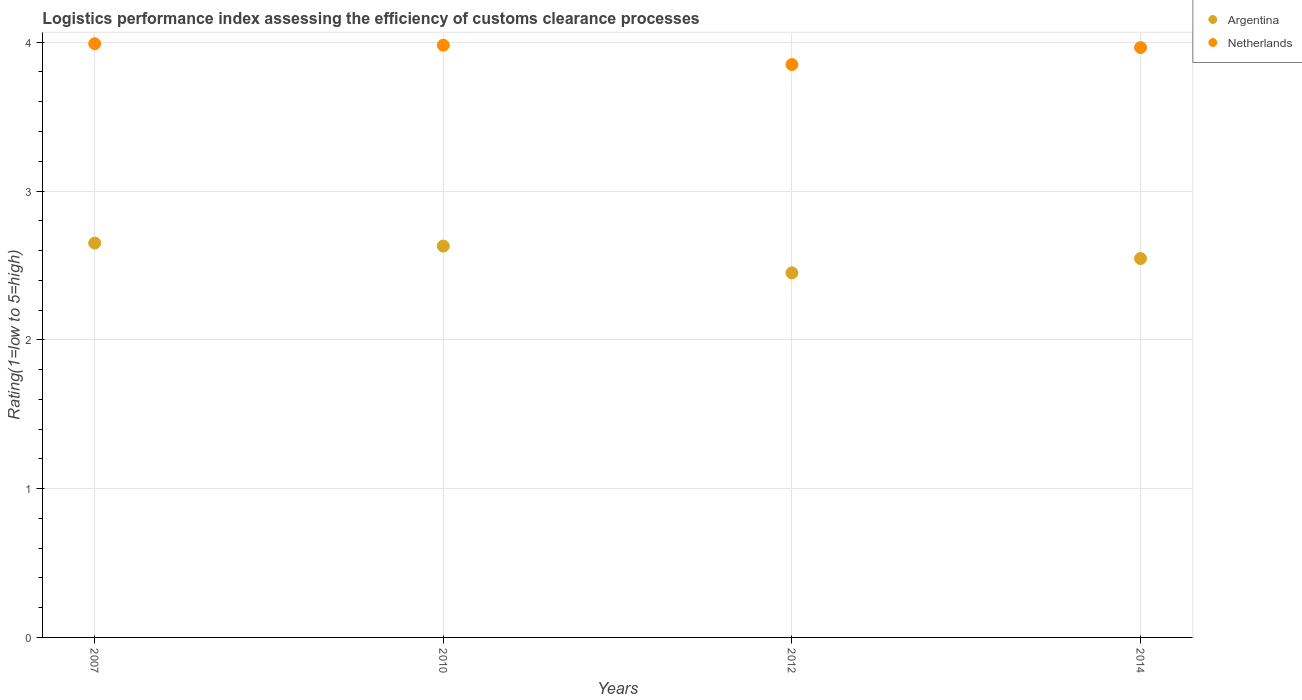Is the number of dotlines equal to the number of legend labels?
Offer a very short reply. Yes. What is the Logistic performance index in Argentina in 2012?
Offer a very short reply. 2.45. Across all years, what is the maximum Logistic performance index in Argentina?
Provide a short and direct response. 2.65. Across all years, what is the minimum Logistic performance index in Netherlands?
Your answer should be compact. 3.85. In which year was the Logistic performance index in Argentina minimum?
Keep it short and to the point. 2012. What is the total Logistic performance index in Argentina in the graph?
Your response must be concise. 10.28. What is the difference between the Logistic performance index in Netherlands in 2007 and that in 2014?
Offer a very short reply. 0.03. What is the difference between the Logistic performance index in Netherlands in 2014 and the Logistic performance index in Argentina in 2012?
Give a very brief answer. 1.51. What is the average Logistic performance index in Netherlands per year?
Your answer should be very brief. 3.95. In the year 2007, what is the difference between the Logistic performance index in Argentina and Logistic performance index in Netherlands?
Make the answer very short. -1.34. In how many years, is the Logistic performance index in Netherlands greater than 0.2?
Offer a very short reply. 4. What is the ratio of the Logistic performance index in Netherlands in 2010 to that in 2014?
Ensure brevity in your answer.  1. What is the difference between the highest and the second highest Logistic performance index in Netherlands?
Your response must be concise. 0.01. What is the difference between the highest and the lowest Logistic performance index in Argentina?
Your answer should be very brief. 0.2. In how many years, is the Logistic performance index in Argentina greater than the average Logistic performance index in Argentina taken over all years?
Your answer should be compact. 2. Is the sum of the Logistic performance index in Netherlands in 2010 and 2012 greater than the maximum Logistic performance index in Argentina across all years?
Provide a short and direct response. Yes. Is the Logistic performance index in Argentina strictly greater than the Logistic performance index in Netherlands over the years?
Make the answer very short. No. Is the Logistic performance index in Netherlands strictly less than the Logistic performance index in Argentina over the years?
Your response must be concise. No. How many years are there in the graph?
Your response must be concise. 4. What is the difference between two consecutive major ticks on the Y-axis?
Provide a short and direct response. 1. Are the values on the major ticks of Y-axis written in scientific E-notation?
Your response must be concise. No. Does the graph contain any zero values?
Your response must be concise. No. Does the graph contain grids?
Give a very brief answer. Yes. How many legend labels are there?
Offer a very short reply. 2. What is the title of the graph?
Provide a succinct answer. Logistics performance index assessing the efficiency of customs clearance processes. Does "Vanuatu" appear as one of the legend labels in the graph?
Your answer should be compact. No. What is the label or title of the X-axis?
Offer a very short reply. Years. What is the label or title of the Y-axis?
Your answer should be compact. Rating(1=low to 5=high). What is the Rating(1=low to 5=high) of Argentina in 2007?
Your answer should be compact. 2.65. What is the Rating(1=low to 5=high) of Netherlands in 2007?
Your answer should be compact. 3.99. What is the Rating(1=low to 5=high) of Argentina in 2010?
Ensure brevity in your answer.  2.63. What is the Rating(1=low to 5=high) in Netherlands in 2010?
Your response must be concise. 3.98. What is the Rating(1=low to 5=high) of Argentina in 2012?
Keep it short and to the point. 2.45. What is the Rating(1=low to 5=high) in Netherlands in 2012?
Offer a very short reply. 3.85. What is the Rating(1=low to 5=high) in Argentina in 2014?
Your response must be concise. 2.55. What is the Rating(1=low to 5=high) of Netherlands in 2014?
Offer a terse response. 3.96. Across all years, what is the maximum Rating(1=low to 5=high) of Argentina?
Your answer should be compact. 2.65. Across all years, what is the maximum Rating(1=low to 5=high) in Netherlands?
Your response must be concise. 3.99. Across all years, what is the minimum Rating(1=low to 5=high) of Argentina?
Offer a very short reply. 2.45. Across all years, what is the minimum Rating(1=low to 5=high) of Netherlands?
Ensure brevity in your answer.  3.85. What is the total Rating(1=low to 5=high) of Argentina in the graph?
Make the answer very short. 10.28. What is the total Rating(1=low to 5=high) in Netherlands in the graph?
Provide a short and direct response. 15.78. What is the difference between the Rating(1=low to 5=high) of Argentina in 2007 and that in 2010?
Your response must be concise. 0.02. What is the difference between the Rating(1=low to 5=high) of Netherlands in 2007 and that in 2012?
Provide a succinct answer. 0.14. What is the difference between the Rating(1=low to 5=high) in Argentina in 2007 and that in 2014?
Your answer should be very brief. 0.1. What is the difference between the Rating(1=low to 5=high) in Netherlands in 2007 and that in 2014?
Offer a very short reply. 0.03. What is the difference between the Rating(1=low to 5=high) in Argentina in 2010 and that in 2012?
Keep it short and to the point. 0.18. What is the difference between the Rating(1=low to 5=high) in Netherlands in 2010 and that in 2012?
Your response must be concise. 0.13. What is the difference between the Rating(1=low to 5=high) of Argentina in 2010 and that in 2014?
Give a very brief answer. 0.08. What is the difference between the Rating(1=low to 5=high) of Netherlands in 2010 and that in 2014?
Offer a very short reply. 0.02. What is the difference between the Rating(1=low to 5=high) of Argentina in 2012 and that in 2014?
Make the answer very short. -0.1. What is the difference between the Rating(1=low to 5=high) of Netherlands in 2012 and that in 2014?
Provide a short and direct response. -0.11. What is the difference between the Rating(1=low to 5=high) of Argentina in 2007 and the Rating(1=low to 5=high) of Netherlands in 2010?
Your answer should be very brief. -1.33. What is the difference between the Rating(1=low to 5=high) of Argentina in 2007 and the Rating(1=low to 5=high) of Netherlands in 2014?
Make the answer very short. -1.31. What is the difference between the Rating(1=low to 5=high) in Argentina in 2010 and the Rating(1=low to 5=high) in Netherlands in 2012?
Keep it short and to the point. -1.22. What is the difference between the Rating(1=low to 5=high) of Argentina in 2010 and the Rating(1=low to 5=high) of Netherlands in 2014?
Offer a very short reply. -1.33. What is the difference between the Rating(1=low to 5=high) in Argentina in 2012 and the Rating(1=low to 5=high) in Netherlands in 2014?
Your response must be concise. -1.51. What is the average Rating(1=low to 5=high) of Argentina per year?
Provide a succinct answer. 2.57. What is the average Rating(1=low to 5=high) of Netherlands per year?
Keep it short and to the point. 3.95. In the year 2007, what is the difference between the Rating(1=low to 5=high) of Argentina and Rating(1=low to 5=high) of Netherlands?
Offer a terse response. -1.34. In the year 2010, what is the difference between the Rating(1=low to 5=high) in Argentina and Rating(1=low to 5=high) in Netherlands?
Provide a succinct answer. -1.35. In the year 2012, what is the difference between the Rating(1=low to 5=high) in Argentina and Rating(1=low to 5=high) in Netherlands?
Keep it short and to the point. -1.4. In the year 2014, what is the difference between the Rating(1=low to 5=high) in Argentina and Rating(1=low to 5=high) in Netherlands?
Provide a short and direct response. -1.42. What is the ratio of the Rating(1=low to 5=high) of Argentina in 2007 to that in 2010?
Offer a very short reply. 1.01. What is the ratio of the Rating(1=low to 5=high) of Netherlands in 2007 to that in 2010?
Your response must be concise. 1. What is the ratio of the Rating(1=low to 5=high) in Argentina in 2007 to that in 2012?
Give a very brief answer. 1.08. What is the ratio of the Rating(1=low to 5=high) in Netherlands in 2007 to that in 2012?
Provide a succinct answer. 1.04. What is the ratio of the Rating(1=low to 5=high) in Argentina in 2007 to that in 2014?
Provide a short and direct response. 1.04. What is the ratio of the Rating(1=low to 5=high) in Netherlands in 2007 to that in 2014?
Offer a terse response. 1.01. What is the ratio of the Rating(1=low to 5=high) in Argentina in 2010 to that in 2012?
Provide a short and direct response. 1.07. What is the ratio of the Rating(1=low to 5=high) of Netherlands in 2010 to that in 2012?
Your answer should be compact. 1.03. What is the ratio of the Rating(1=low to 5=high) of Argentina in 2010 to that in 2014?
Provide a short and direct response. 1.03. What is the ratio of the Rating(1=low to 5=high) of Argentina in 2012 to that in 2014?
Give a very brief answer. 0.96. What is the ratio of the Rating(1=low to 5=high) in Netherlands in 2012 to that in 2014?
Provide a succinct answer. 0.97. What is the difference between the highest and the second highest Rating(1=low to 5=high) in Argentina?
Offer a very short reply. 0.02. What is the difference between the highest and the lowest Rating(1=low to 5=high) in Netherlands?
Offer a terse response. 0.14. 